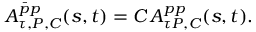Convert formula to latex. <formula><loc_0><loc_0><loc_500><loc_500>A _ { \tau , P , C } ^ { \bar { p } p } ( s , t ) = C \, A _ { \tau P , C } ^ { p p } ( s , t ) .</formula> 